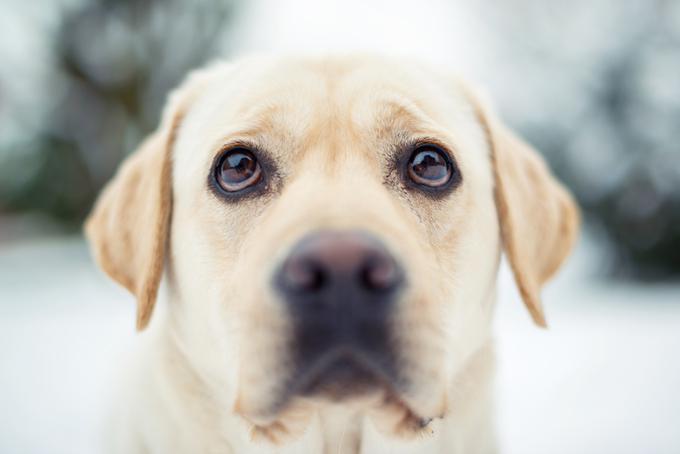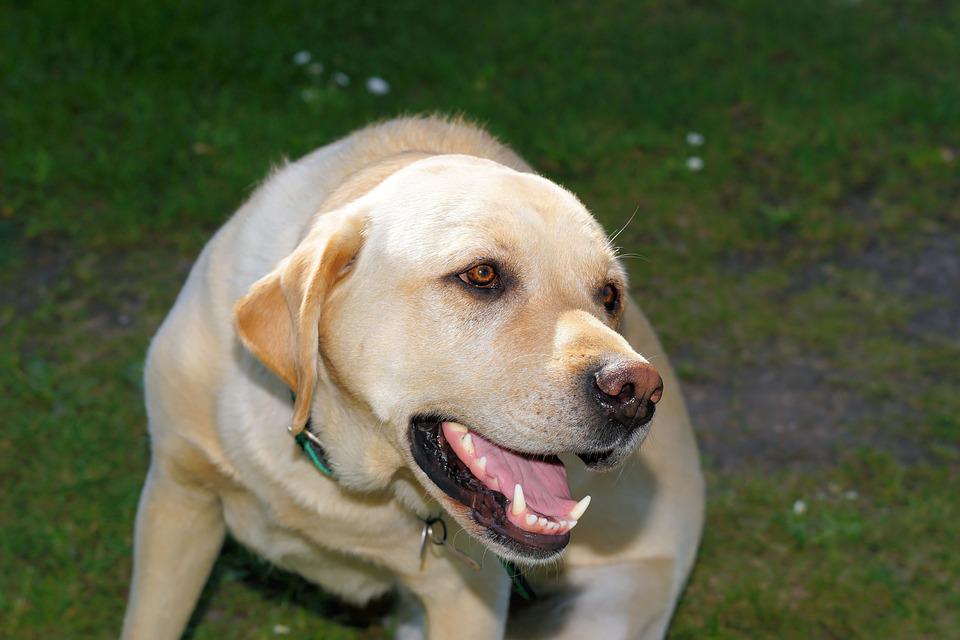The first image is the image on the left, the second image is the image on the right. Analyze the images presented: Is the assertion "One of the images shows a dog with a dog toy in their possession." valid? Answer yes or no. No. The first image is the image on the left, the second image is the image on the right. Considering the images on both sides, is "one of the dogs is showing its teeth" valid? Answer yes or no. Yes. 